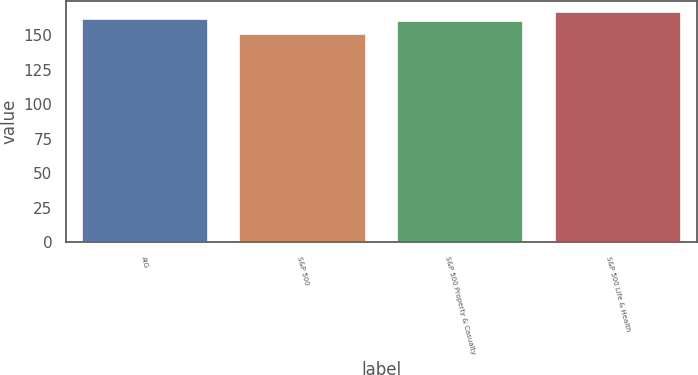Convert chart to OTSL. <chart><loc_0><loc_0><loc_500><loc_500><bar_chart><fcel>AIG<fcel>S&P 500<fcel>S&P 500 Property & Casualty<fcel>S&P 500 Life & Health<nl><fcel>161.68<fcel>150.51<fcel>160.06<fcel>166.66<nl></chart> 